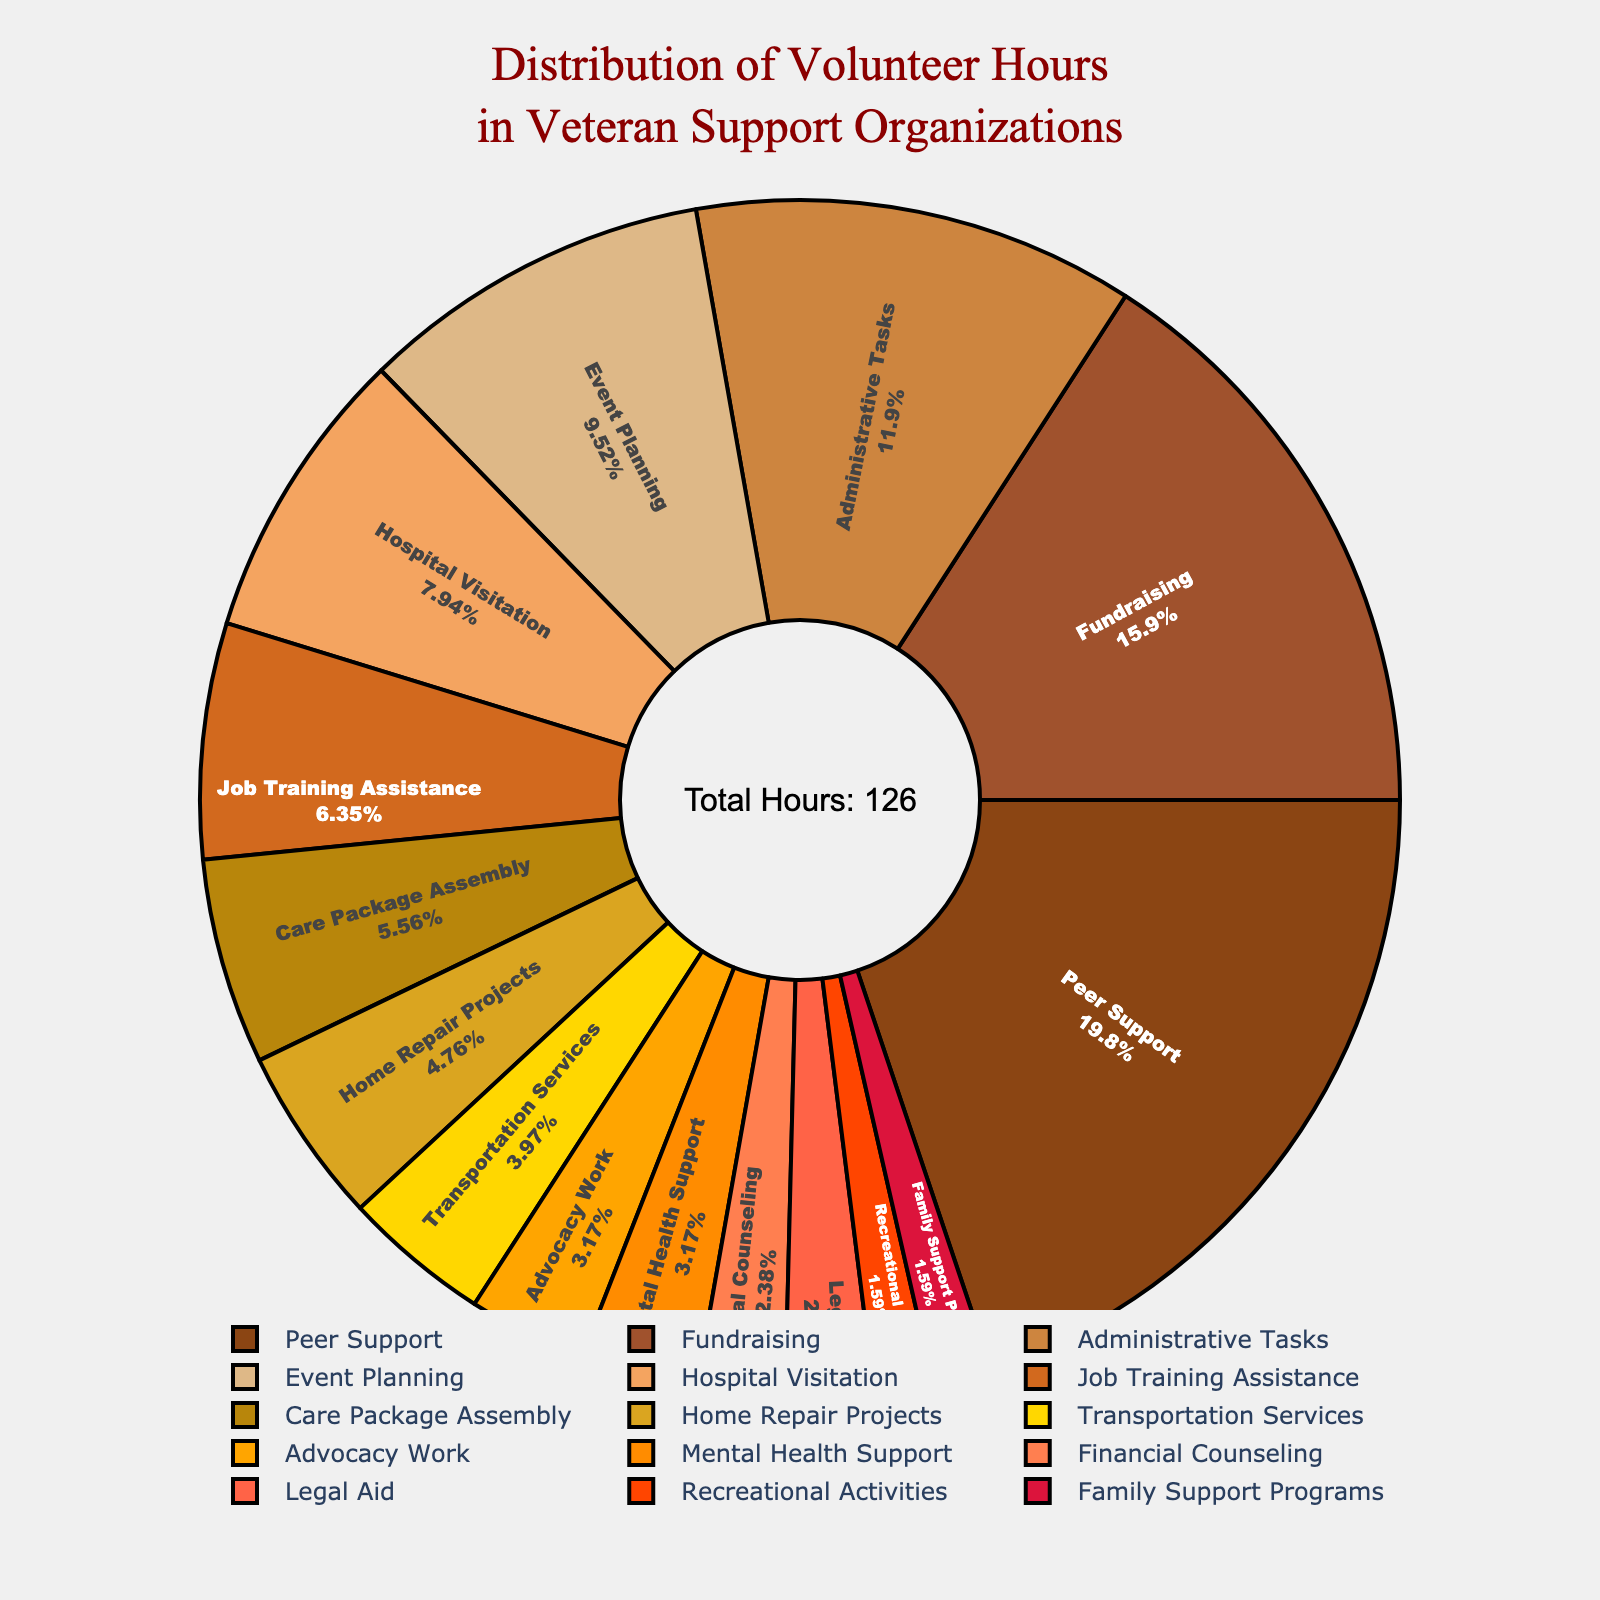What's the activity with the highest volunteer hours? By observing the size of the pie slices and the labels, the largest slice corresponds to Peer Support.
Answer: Peer Support Which activity has the smallest percentage of total volunteer hours? The smallest slice in the pie chart is labeled, and it corresponds to Family Support Programs.
Answer: Family Support Programs What's the total number of volunteer hours represented in the chart? The annotation in the center of the pie chart states the total number of hours, which sums up to 126 hours.
Answer: 126 How many more hours are spent on Peer Support compared to Advocacy Work? Peer Support has 25 hours and Advocacy Work has 4 hours. The difference is 25 - 4 = 21 hours.
Answer: 21 What’s the combined percentage of hours spent on Administrative Tasks and Event Planning? The pie chart shows the percentage for each activity. Administrative Tasks (15 hours) and Event Planning (12 hours) together account for about 21.43% of the total volunteer hours (since 27/126 ≈ 21.43%).
Answer: 21.43% Which activities involve fewer than 5 volunteer hours? From the pie chart, the activities with fewer than 5 hours are Financial Counseling, Legal Aid, Recreational Activities, and Family Support Programs.
Answer: Financial Counseling, Legal Aid, Recreational Activities, Family Support Programs What is the difference in percentage between Fundraising and Home Repair Projects? Fundraising contributes 20 hours and Home Repair Projects contribute 6 hours. Calculate their percentages (20/126 ≈ 15.87% and 6/126 ≈ 4.76%). The difference is approximately 15.87% - 4.76% = 11.11%.
Answer: 11.11% Which activity has an equal or almost equal number of volunteer hours as Hospital Visitation? Hospital Visitation has 10 hours of volunteer time. Job Training Assistance comes close with 8 hours.
Answer: Job Training Assistance What is the percentage of total volunteer hours for Care Package Assembly? Care Package Assembly takes up 7 hours. Its percentage is approximately calculated as (7/126) × 100% which is approximately 5.56%.
Answer: 5.56% Among Peer Support, Fundraising, and Administrative Tasks, which has the lowest volunteer hours and by how much? Peer Support is 25 hours, Fundraising is 20 hours, Administrative Tasks is 15 hours. Administrative Tasks has the lowest with Peer Support having 10 hours more and Fundraising 5 hours more.
Answer: Administrative Tasks, by 10 and 5 hours 